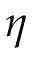Convert formula to latex. <formula><loc_0><loc_0><loc_500><loc_500>\eta</formula> 